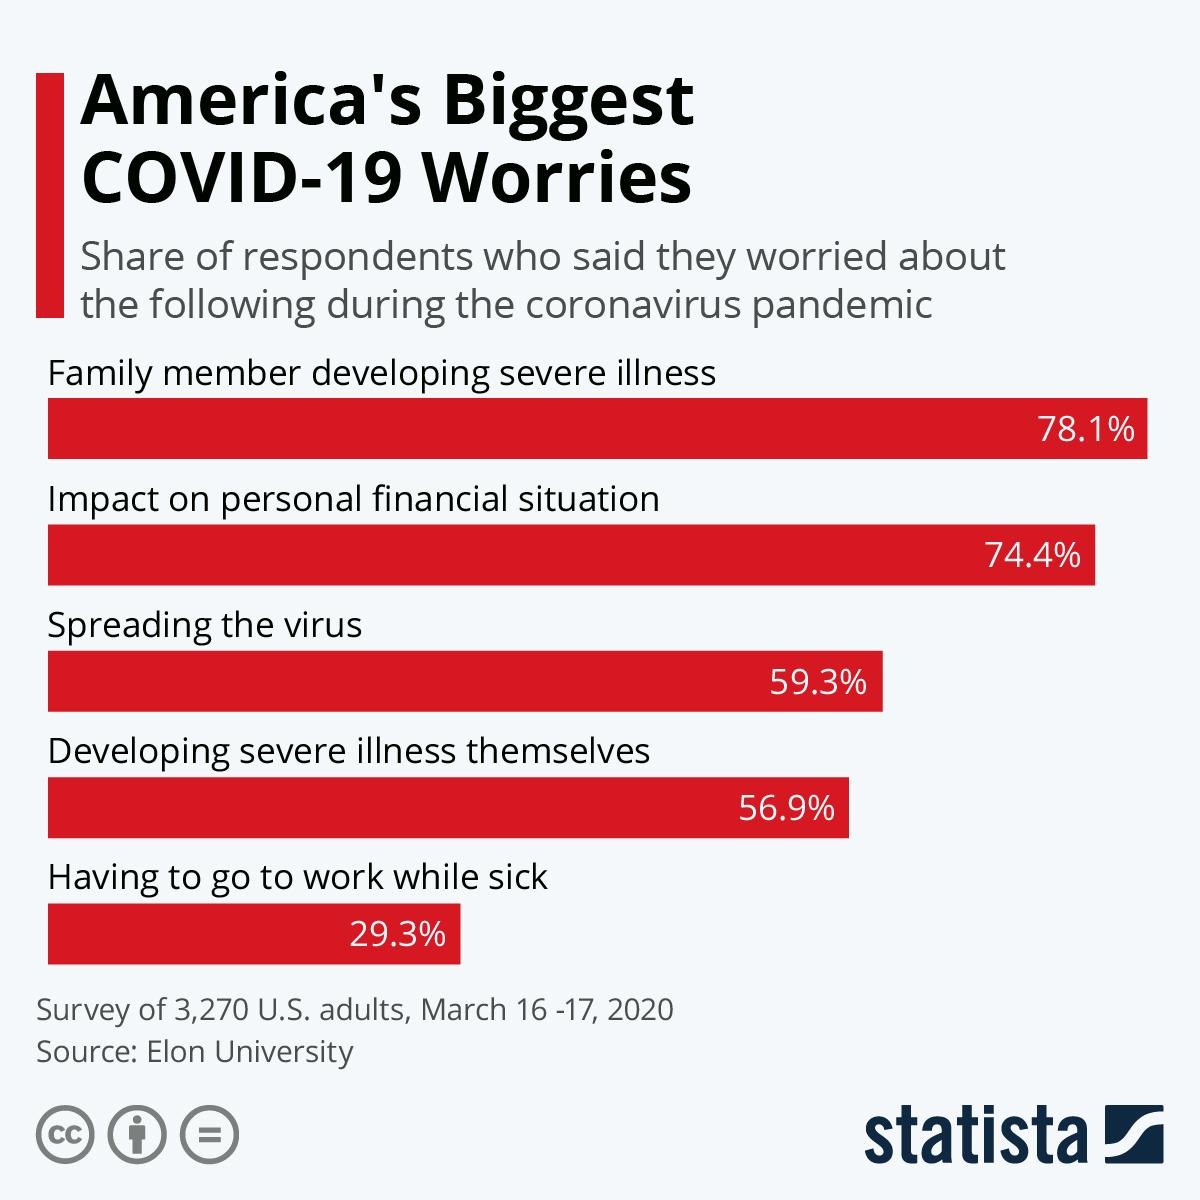Mention a couple of crucial points in this snapshot. According to the survey, a majority of people, 59.3%, are worried about spreading the disease. The speaker was concerned about having to go to work despite being sick, as it was the least worrisome matter for them. 